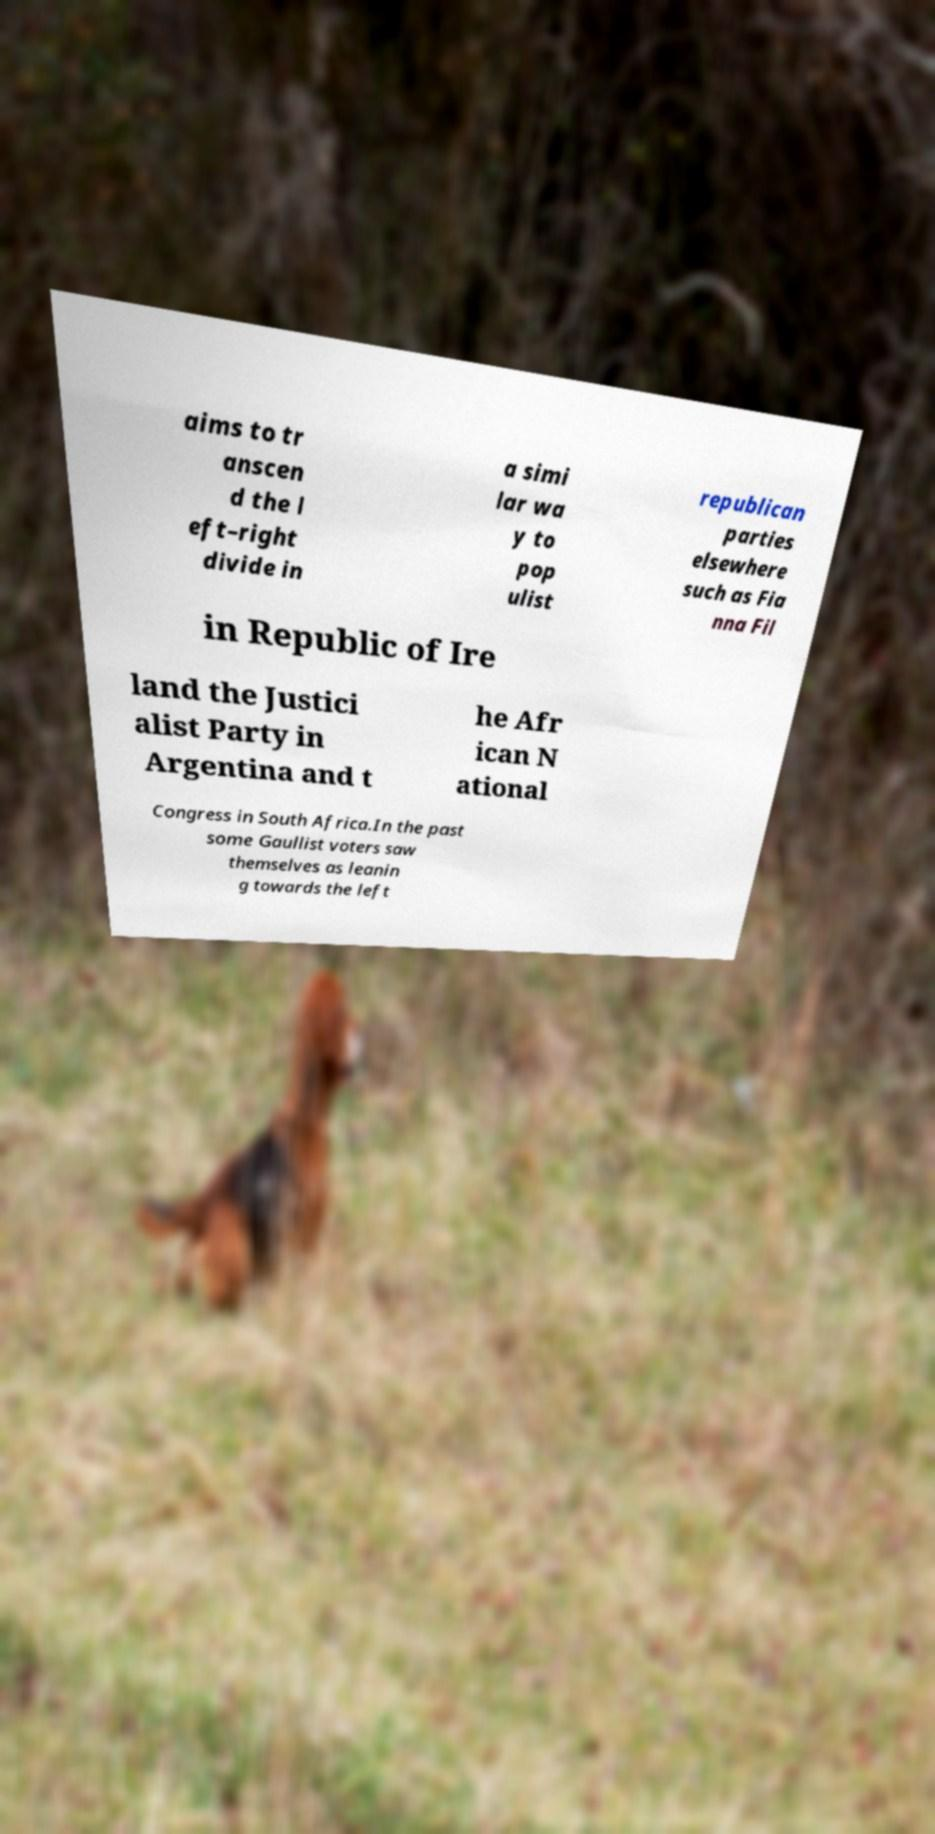There's text embedded in this image that I need extracted. Can you transcribe it verbatim? aims to tr anscen d the l eft–right divide in a simi lar wa y to pop ulist republican parties elsewhere such as Fia nna Fil in Republic of Ire land the Justici alist Party in Argentina and t he Afr ican N ational Congress in South Africa.In the past some Gaullist voters saw themselves as leanin g towards the left 